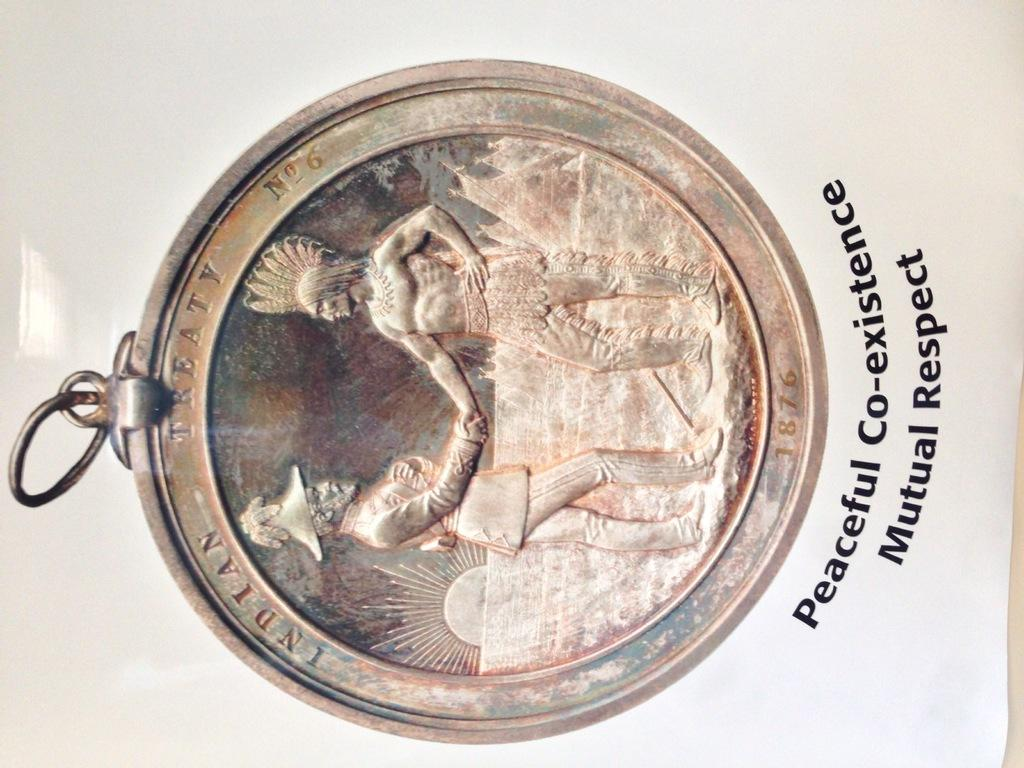<image>
Relay a brief, clear account of the picture shown. A coin with the caption Peaceful Co-existence Mutual Respect. 